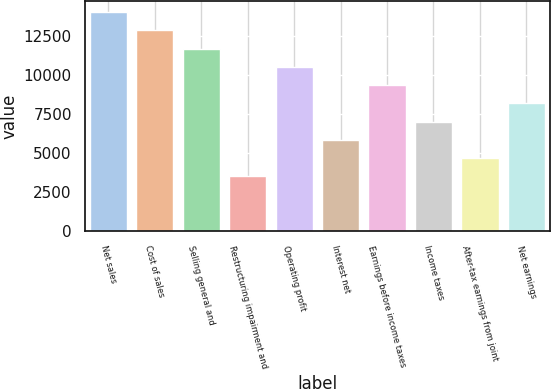Convert chart. <chart><loc_0><loc_0><loc_500><loc_500><bar_chart><fcel>Net sales<fcel>Cost of sales<fcel>Selling general and<fcel>Restructuring impairment and<fcel>Operating profit<fcel>Interest net<fcel>Earnings before income taxes<fcel>Income taxes<fcel>After-tax earnings from joint<fcel>Net earnings<nl><fcel>14053.3<fcel>12882.3<fcel>11711.3<fcel>3514.34<fcel>10540.3<fcel>5856.34<fcel>9369.34<fcel>7027.34<fcel>4685.34<fcel>8198.34<nl></chart> 